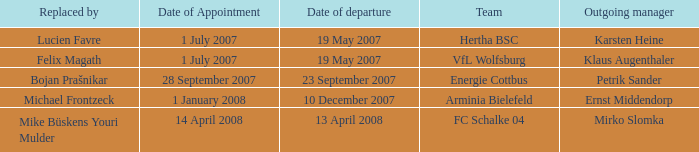When was the departure date when a manager was replaced by Bojan Prašnikar? 23 September 2007. 